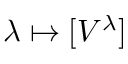<formula> <loc_0><loc_0><loc_500><loc_500>\lambda \mapsto [ V ^ { \lambda } ]</formula> 